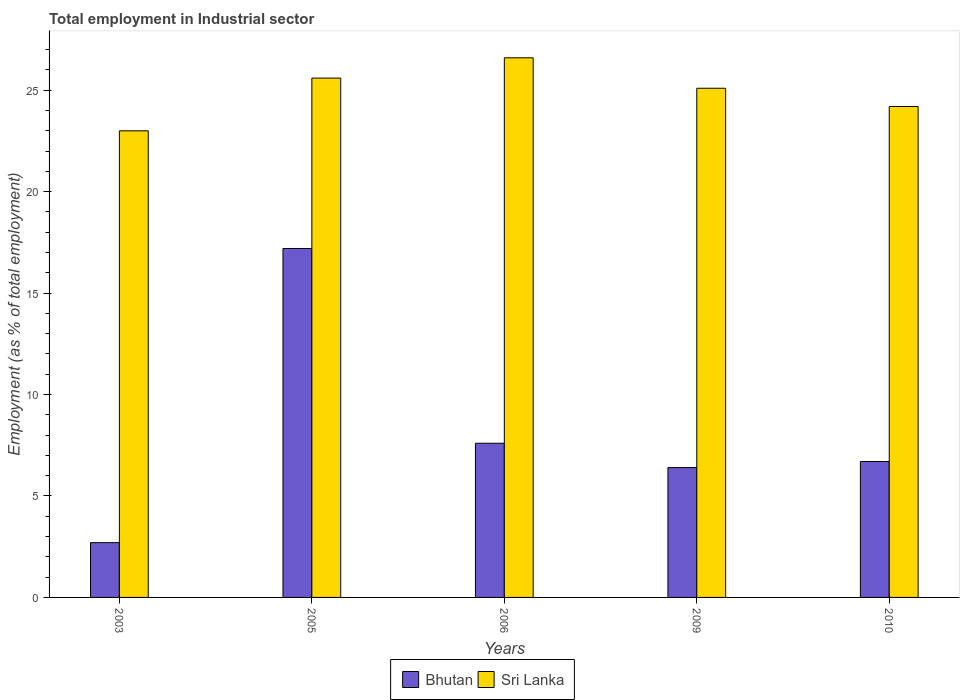How many different coloured bars are there?
Give a very brief answer. 2. How many bars are there on the 3rd tick from the right?
Keep it short and to the point. 2. What is the employment in industrial sector in Sri Lanka in 2006?
Your response must be concise. 26.6. Across all years, what is the maximum employment in industrial sector in Bhutan?
Keep it short and to the point. 17.2. In which year was the employment in industrial sector in Sri Lanka maximum?
Your answer should be compact. 2006. In which year was the employment in industrial sector in Sri Lanka minimum?
Offer a very short reply. 2003. What is the total employment in industrial sector in Bhutan in the graph?
Your answer should be very brief. 40.6. What is the difference between the employment in industrial sector in Bhutan in 2006 and that in 2009?
Your response must be concise. 1.2. What is the difference between the employment in industrial sector in Bhutan in 2003 and the employment in industrial sector in Sri Lanka in 2005?
Offer a very short reply. -22.9. What is the average employment in industrial sector in Sri Lanka per year?
Provide a short and direct response. 24.9. In the year 2003, what is the difference between the employment in industrial sector in Bhutan and employment in industrial sector in Sri Lanka?
Make the answer very short. -20.3. In how many years, is the employment in industrial sector in Bhutan greater than 26 %?
Ensure brevity in your answer.  0. What is the ratio of the employment in industrial sector in Sri Lanka in 2003 to that in 2009?
Provide a succinct answer. 0.92. Is the employment in industrial sector in Sri Lanka in 2003 less than that in 2010?
Make the answer very short. Yes. What is the difference between the highest and the second highest employment in industrial sector in Bhutan?
Give a very brief answer. 9.6. What is the difference between the highest and the lowest employment in industrial sector in Sri Lanka?
Make the answer very short. 3.6. In how many years, is the employment in industrial sector in Bhutan greater than the average employment in industrial sector in Bhutan taken over all years?
Offer a terse response. 1. What does the 1st bar from the left in 2003 represents?
Offer a very short reply. Bhutan. What does the 2nd bar from the right in 2006 represents?
Provide a succinct answer. Bhutan. How many bars are there?
Ensure brevity in your answer.  10. Are all the bars in the graph horizontal?
Provide a short and direct response. No. What is the difference between two consecutive major ticks on the Y-axis?
Your response must be concise. 5. Are the values on the major ticks of Y-axis written in scientific E-notation?
Ensure brevity in your answer.  No. Does the graph contain any zero values?
Give a very brief answer. No. Does the graph contain grids?
Keep it short and to the point. No. How many legend labels are there?
Provide a short and direct response. 2. How are the legend labels stacked?
Provide a short and direct response. Horizontal. What is the title of the graph?
Keep it short and to the point. Total employment in Industrial sector. Does "Mauritius" appear as one of the legend labels in the graph?
Provide a short and direct response. No. What is the label or title of the Y-axis?
Keep it short and to the point. Employment (as % of total employment). What is the Employment (as % of total employment) of Bhutan in 2003?
Offer a terse response. 2.7. What is the Employment (as % of total employment) in Sri Lanka in 2003?
Ensure brevity in your answer.  23. What is the Employment (as % of total employment) in Bhutan in 2005?
Make the answer very short. 17.2. What is the Employment (as % of total employment) of Sri Lanka in 2005?
Make the answer very short. 25.6. What is the Employment (as % of total employment) of Bhutan in 2006?
Your answer should be compact. 7.6. What is the Employment (as % of total employment) in Sri Lanka in 2006?
Provide a short and direct response. 26.6. What is the Employment (as % of total employment) of Bhutan in 2009?
Your response must be concise. 6.4. What is the Employment (as % of total employment) in Sri Lanka in 2009?
Provide a short and direct response. 25.1. What is the Employment (as % of total employment) in Bhutan in 2010?
Your answer should be very brief. 6.7. What is the Employment (as % of total employment) in Sri Lanka in 2010?
Your answer should be very brief. 24.2. Across all years, what is the maximum Employment (as % of total employment) in Bhutan?
Your answer should be compact. 17.2. Across all years, what is the maximum Employment (as % of total employment) in Sri Lanka?
Your answer should be compact. 26.6. Across all years, what is the minimum Employment (as % of total employment) of Bhutan?
Your answer should be very brief. 2.7. What is the total Employment (as % of total employment) in Bhutan in the graph?
Provide a succinct answer. 40.6. What is the total Employment (as % of total employment) of Sri Lanka in the graph?
Your answer should be compact. 124.5. What is the difference between the Employment (as % of total employment) in Bhutan in 2003 and that in 2005?
Offer a very short reply. -14.5. What is the difference between the Employment (as % of total employment) of Bhutan in 2003 and that in 2006?
Ensure brevity in your answer.  -4.9. What is the difference between the Employment (as % of total employment) in Bhutan in 2003 and that in 2010?
Your answer should be compact. -4. What is the difference between the Employment (as % of total employment) in Sri Lanka in 2003 and that in 2010?
Ensure brevity in your answer.  -1.2. What is the difference between the Employment (as % of total employment) in Bhutan in 2005 and that in 2006?
Keep it short and to the point. 9.6. What is the difference between the Employment (as % of total employment) in Sri Lanka in 2005 and that in 2006?
Provide a succinct answer. -1. What is the difference between the Employment (as % of total employment) in Sri Lanka in 2005 and that in 2009?
Keep it short and to the point. 0.5. What is the difference between the Employment (as % of total employment) of Bhutan in 2005 and that in 2010?
Your response must be concise. 10.5. What is the difference between the Employment (as % of total employment) in Sri Lanka in 2005 and that in 2010?
Your answer should be very brief. 1.4. What is the difference between the Employment (as % of total employment) in Bhutan in 2006 and that in 2009?
Ensure brevity in your answer.  1.2. What is the difference between the Employment (as % of total employment) in Bhutan in 2006 and that in 2010?
Give a very brief answer. 0.9. What is the difference between the Employment (as % of total employment) of Bhutan in 2009 and that in 2010?
Give a very brief answer. -0.3. What is the difference between the Employment (as % of total employment) of Bhutan in 2003 and the Employment (as % of total employment) of Sri Lanka in 2005?
Offer a very short reply. -22.9. What is the difference between the Employment (as % of total employment) of Bhutan in 2003 and the Employment (as % of total employment) of Sri Lanka in 2006?
Your answer should be compact. -23.9. What is the difference between the Employment (as % of total employment) of Bhutan in 2003 and the Employment (as % of total employment) of Sri Lanka in 2009?
Provide a succinct answer. -22.4. What is the difference between the Employment (as % of total employment) of Bhutan in 2003 and the Employment (as % of total employment) of Sri Lanka in 2010?
Provide a short and direct response. -21.5. What is the difference between the Employment (as % of total employment) of Bhutan in 2005 and the Employment (as % of total employment) of Sri Lanka in 2006?
Your answer should be compact. -9.4. What is the difference between the Employment (as % of total employment) in Bhutan in 2005 and the Employment (as % of total employment) in Sri Lanka in 2009?
Keep it short and to the point. -7.9. What is the difference between the Employment (as % of total employment) in Bhutan in 2005 and the Employment (as % of total employment) in Sri Lanka in 2010?
Provide a short and direct response. -7. What is the difference between the Employment (as % of total employment) of Bhutan in 2006 and the Employment (as % of total employment) of Sri Lanka in 2009?
Offer a terse response. -17.5. What is the difference between the Employment (as % of total employment) of Bhutan in 2006 and the Employment (as % of total employment) of Sri Lanka in 2010?
Give a very brief answer. -16.6. What is the difference between the Employment (as % of total employment) in Bhutan in 2009 and the Employment (as % of total employment) in Sri Lanka in 2010?
Provide a short and direct response. -17.8. What is the average Employment (as % of total employment) of Bhutan per year?
Provide a short and direct response. 8.12. What is the average Employment (as % of total employment) of Sri Lanka per year?
Provide a short and direct response. 24.9. In the year 2003, what is the difference between the Employment (as % of total employment) in Bhutan and Employment (as % of total employment) in Sri Lanka?
Your response must be concise. -20.3. In the year 2009, what is the difference between the Employment (as % of total employment) in Bhutan and Employment (as % of total employment) in Sri Lanka?
Ensure brevity in your answer.  -18.7. In the year 2010, what is the difference between the Employment (as % of total employment) in Bhutan and Employment (as % of total employment) in Sri Lanka?
Keep it short and to the point. -17.5. What is the ratio of the Employment (as % of total employment) of Bhutan in 2003 to that in 2005?
Provide a succinct answer. 0.16. What is the ratio of the Employment (as % of total employment) in Sri Lanka in 2003 to that in 2005?
Keep it short and to the point. 0.9. What is the ratio of the Employment (as % of total employment) in Bhutan in 2003 to that in 2006?
Provide a short and direct response. 0.36. What is the ratio of the Employment (as % of total employment) in Sri Lanka in 2003 to that in 2006?
Ensure brevity in your answer.  0.86. What is the ratio of the Employment (as % of total employment) in Bhutan in 2003 to that in 2009?
Offer a very short reply. 0.42. What is the ratio of the Employment (as % of total employment) in Sri Lanka in 2003 to that in 2009?
Provide a short and direct response. 0.92. What is the ratio of the Employment (as % of total employment) of Bhutan in 2003 to that in 2010?
Offer a terse response. 0.4. What is the ratio of the Employment (as % of total employment) in Sri Lanka in 2003 to that in 2010?
Provide a succinct answer. 0.95. What is the ratio of the Employment (as % of total employment) of Bhutan in 2005 to that in 2006?
Your response must be concise. 2.26. What is the ratio of the Employment (as % of total employment) of Sri Lanka in 2005 to that in 2006?
Offer a terse response. 0.96. What is the ratio of the Employment (as % of total employment) in Bhutan in 2005 to that in 2009?
Provide a succinct answer. 2.69. What is the ratio of the Employment (as % of total employment) of Sri Lanka in 2005 to that in 2009?
Keep it short and to the point. 1.02. What is the ratio of the Employment (as % of total employment) in Bhutan in 2005 to that in 2010?
Provide a short and direct response. 2.57. What is the ratio of the Employment (as % of total employment) in Sri Lanka in 2005 to that in 2010?
Your answer should be compact. 1.06. What is the ratio of the Employment (as % of total employment) in Bhutan in 2006 to that in 2009?
Provide a short and direct response. 1.19. What is the ratio of the Employment (as % of total employment) of Sri Lanka in 2006 to that in 2009?
Your answer should be compact. 1.06. What is the ratio of the Employment (as % of total employment) in Bhutan in 2006 to that in 2010?
Ensure brevity in your answer.  1.13. What is the ratio of the Employment (as % of total employment) in Sri Lanka in 2006 to that in 2010?
Your answer should be compact. 1.1. What is the ratio of the Employment (as % of total employment) in Bhutan in 2009 to that in 2010?
Make the answer very short. 0.96. What is the ratio of the Employment (as % of total employment) of Sri Lanka in 2009 to that in 2010?
Your response must be concise. 1.04. What is the difference between the highest and the second highest Employment (as % of total employment) of Sri Lanka?
Ensure brevity in your answer.  1. 